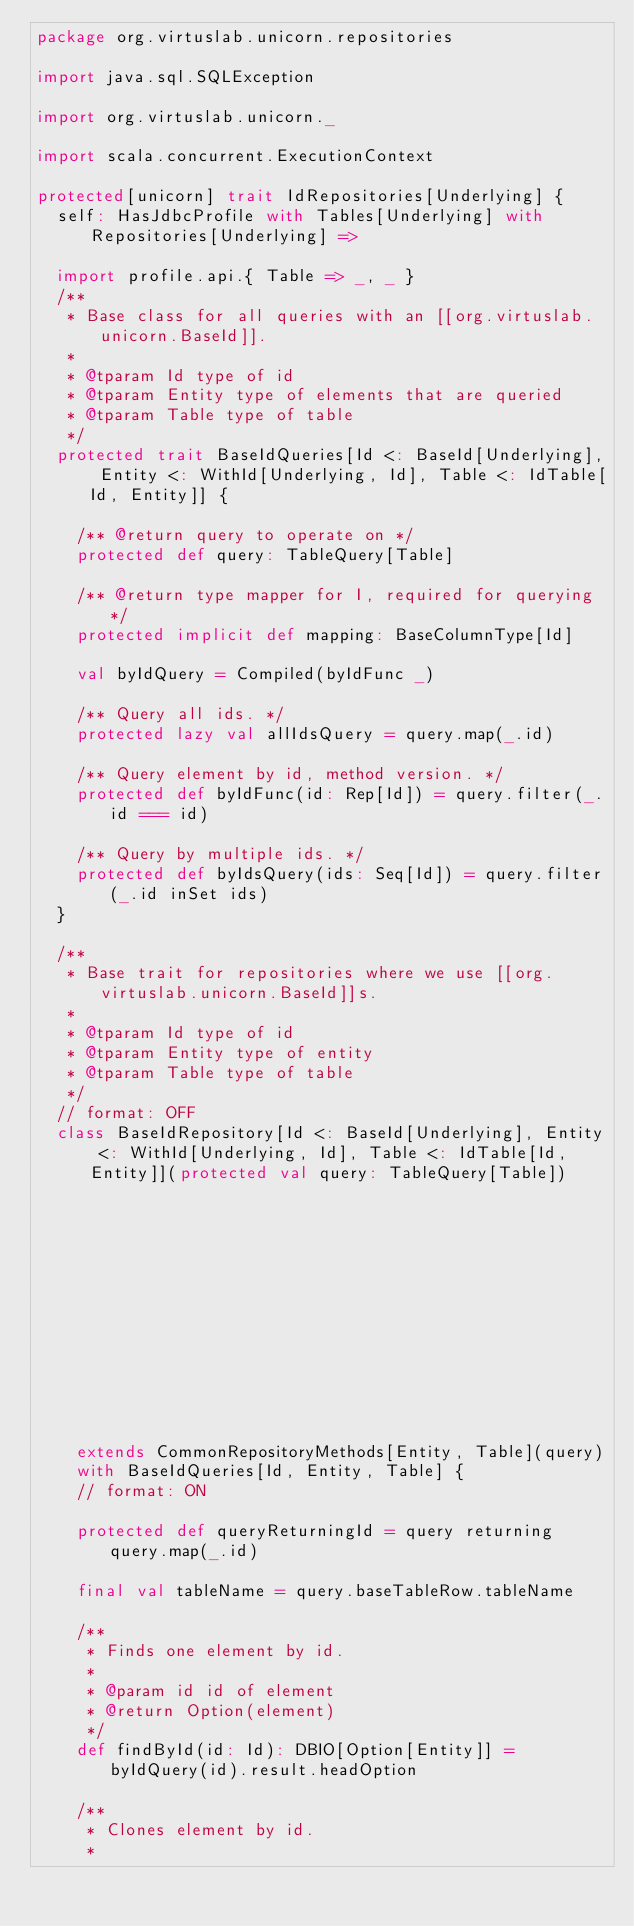Convert code to text. <code><loc_0><loc_0><loc_500><loc_500><_Scala_>package org.virtuslab.unicorn.repositories

import java.sql.SQLException

import org.virtuslab.unicorn._

import scala.concurrent.ExecutionContext

protected[unicorn] trait IdRepositories[Underlying] {
  self: HasJdbcProfile with Tables[Underlying] with Repositories[Underlying] =>

  import profile.api.{ Table => _, _ }
  /**
   * Base class for all queries with an [[org.virtuslab.unicorn.BaseId]].
   *
   * @tparam Id type of id
   * @tparam Entity type of elements that are queried
   * @tparam Table type of table
   */
  protected trait BaseIdQueries[Id <: BaseId[Underlying], Entity <: WithId[Underlying, Id], Table <: IdTable[Id, Entity]] {

    /** @return query to operate on */
    protected def query: TableQuery[Table]

    /** @return type mapper for I, required for querying */
    protected implicit def mapping: BaseColumnType[Id]

    val byIdQuery = Compiled(byIdFunc _)

    /** Query all ids. */
    protected lazy val allIdsQuery = query.map(_.id)

    /** Query element by id, method version. */
    protected def byIdFunc(id: Rep[Id]) = query.filter(_.id === id)

    /** Query by multiple ids. */
    protected def byIdsQuery(ids: Seq[Id]) = query.filter(_.id inSet ids)
  }

  /**
   * Base trait for repositories where we use [[org.virtuslab.unicorn.BaseId]]s.
   *
   * @tparam Id type of id
   * @tparam Entity type of entity
   * @tparam Table type of table
   */
  // format: OFF
  class BaseIdRepository[Id <: BaseId[Underlying], Entity <: WithId[Underlying, Id], Table <: IdTable[Id, Entity]](protected val query: TableQuery[Table])
                                                                                          (implicit val mapping: BaseColumnType[Id])
    extends CommonRepositoryMethods[Entity, Table](query)
    with BaseIdQueries[Id, Entity, Table] {
    // format: ON

    protected def queryReturningId = query returning query.map(_.id)

    final val tableName = query.baseTableRow.tableName

    /**
     * Finds one element by id.
     *
     * @param id id of element
     * @return Option(element)
     */
    def findById(id: Id): DBIO[Option[Entity]] = byIdQuery(id).result.headOption

    /**
     * Clones element by id.
     *</code> 